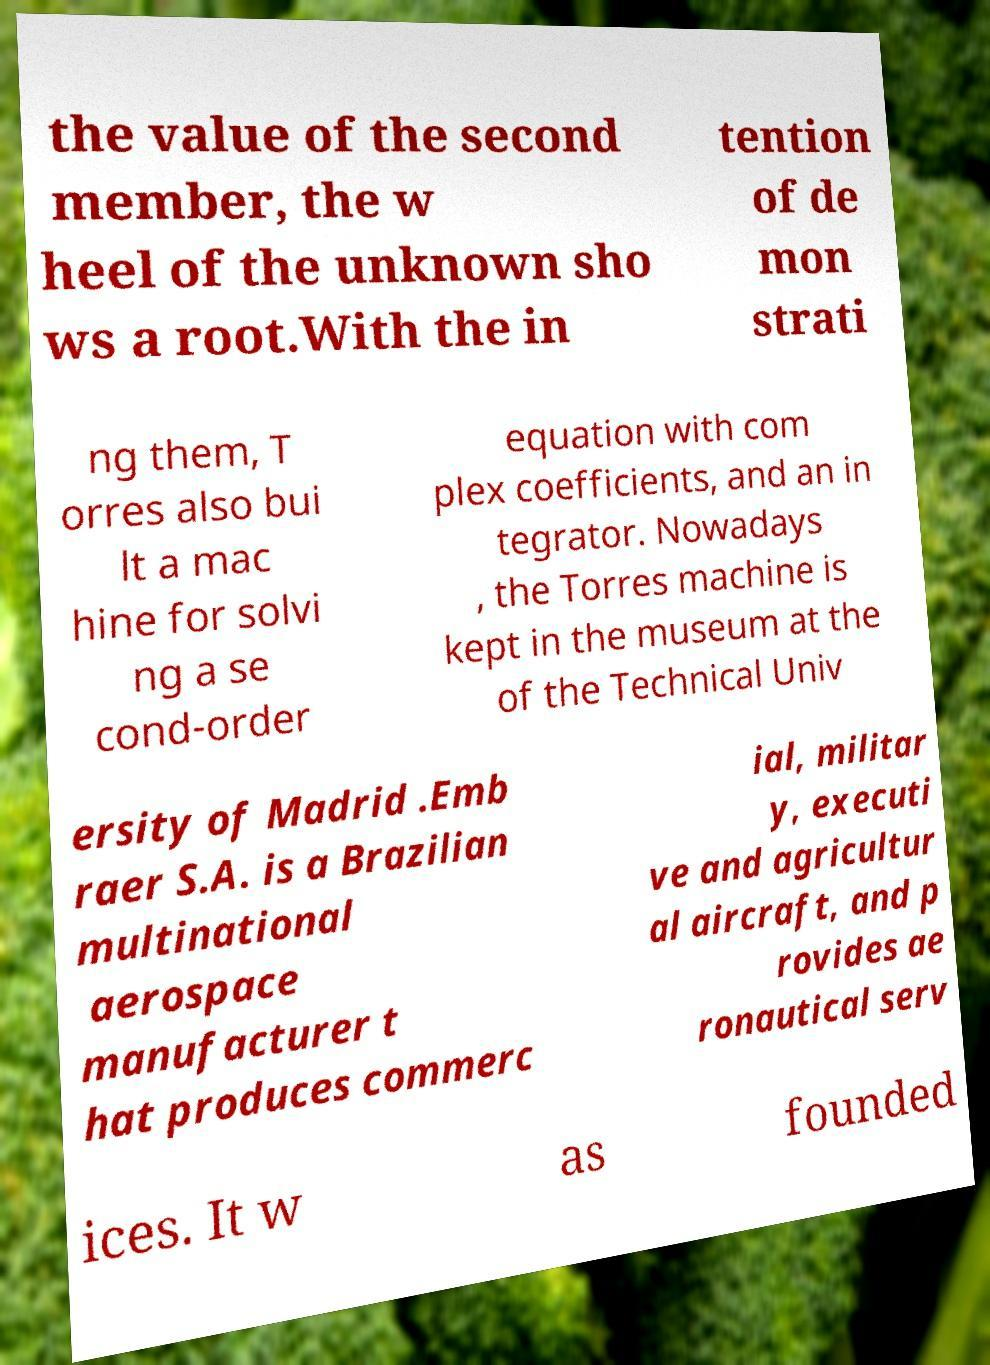I need the written content from this picture converted into text. Can you do that? the value of the second member, the w heel of the unknown sho ws a root.With the in tention of de mon strati ng them, T orres also bui lt a mac hine for solvi ng a se cond-order equation with com plex coefficients, and an in tegrator. Nowadays , the Torres machine is kept in the museum at the of the Technical Univ ersity of Madrid .Emb raer S.A. is a Brazilian multinational aerospace manufacturer t hat produces commerc ial, militar y, executi ve and agricultur al aircraft, and p rovides ae ronautical serv ices. It w as founded 